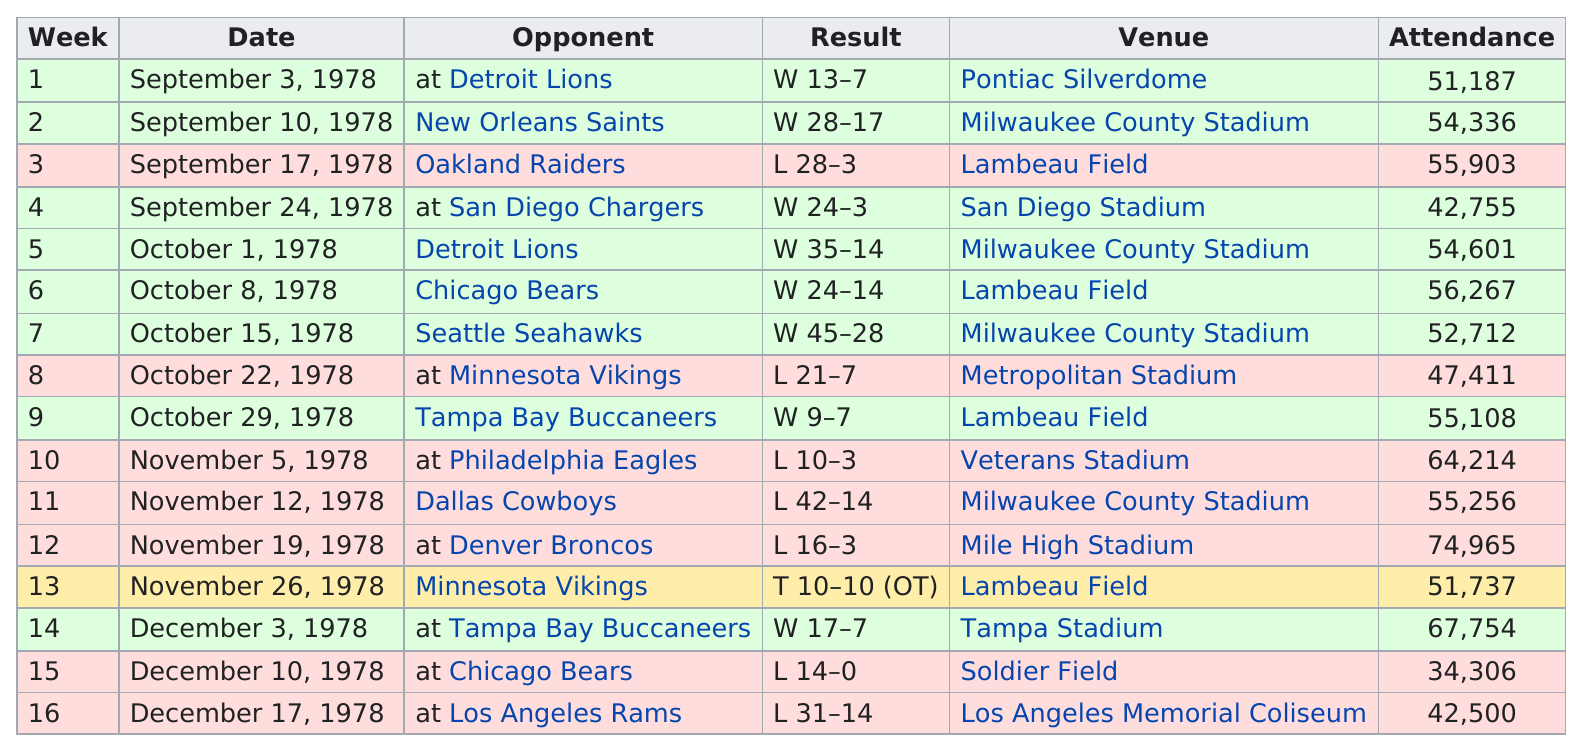Indicate a few pertinent items in this graphic. The Los Angeles Rams were the last team that was played. On November 19, 1978, the Pittsburgh Steelers faced the Denver Broncos and scored 13 points. The difference in score in week 7 was 17. The first game took place at the Pontiac Silverdome. The most games were played in the month of October. 